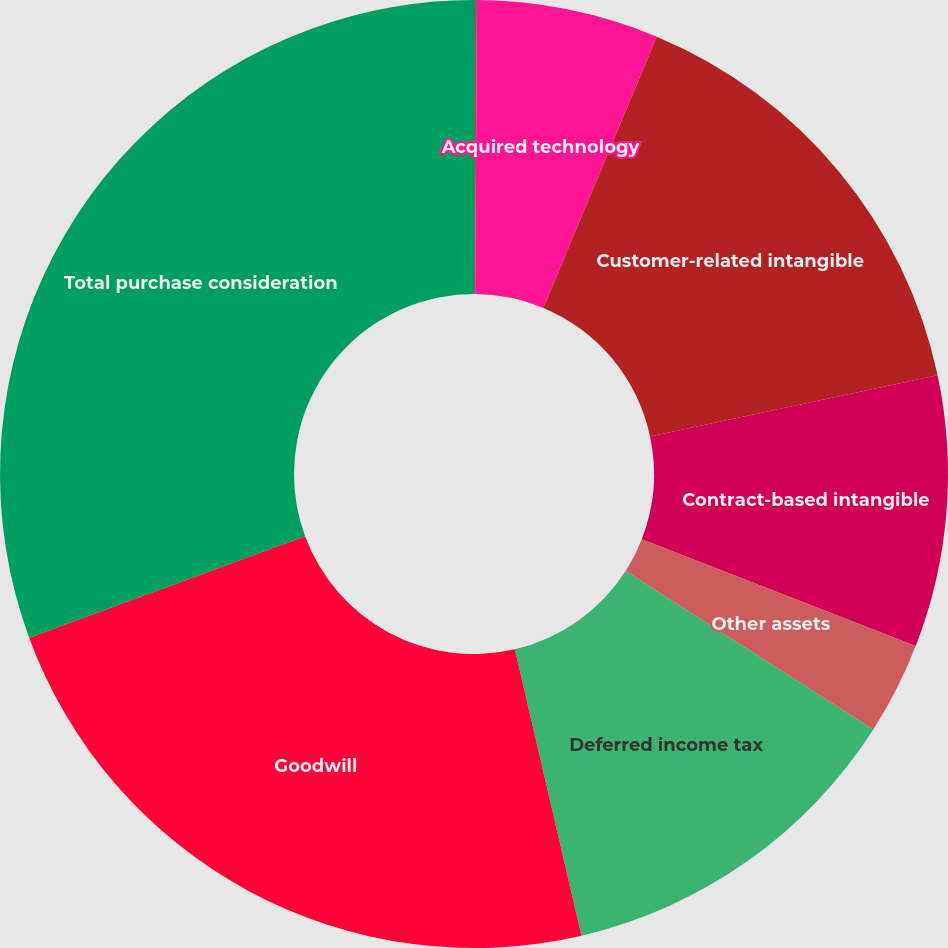Convert chart. <chart><loc_0><loc_0><loc_500><loc_500><pie_chart><fcel>Property and equipment<fcel>Acquired technology<fcel>Customer-related intangible<fcel>Contract-based intangible<fcel>Other assets<fcel>Deferred income tax<fcel>Goodwill<fcel>Total purchase consideration<nl><fcel>0.1%<fcel>6.2%<fcel>15.36%<fcel>9.25%<fcel>3.15%<fcel>12.3%<fcel>23.03%<fcel>30.61%<nl></chart> 